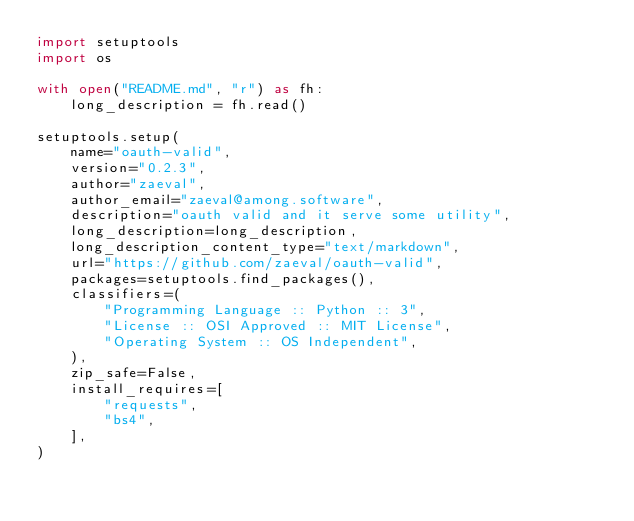Convert code to text. <code><loc_0><loc_0><loc_500><loc_500><_Python_>import setuptools
import os

with open("README.md", "r") as fh:
    long_description = fh.read()

setuptools.setup(
    name="oauth-valid",
    version="0.2.3",
    author="zaeval",
    author_email="zaeval@among.software",
    description="oauth valid and it serve some utility",
    long_description=long_description,
    long_description_content_type="text/markdown",
    url="https://github.com/zaeval/oauth-valid",
    packages=setuptools.find_packages(),
    classifiers=(
        "Programming Language :: Python :: 3",
        "License :: OSI Approved :: MIT License",
        "Operating System :: OS Independent",
    ),
    zip_safe=False,
    install_requires=[
        "requests",
        "bs4",
    ],
)
</code> 